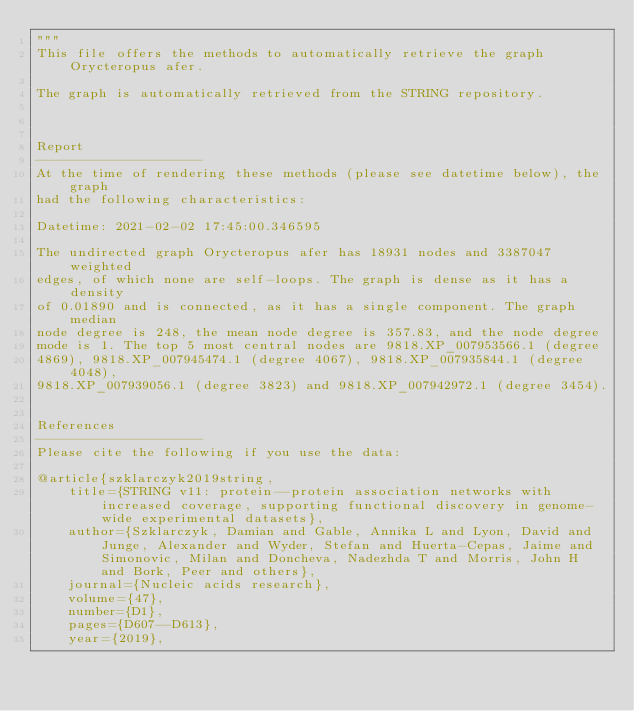Convert code to text. <code><loc_0><loc_0><loc_500><loc_500><_Python_>"""
This file offers the methods to automatically retrieve the graph Orycteropus afer.

The graph is automatically retrieved from the STRING repository. 



Report
---------------------
At the time of rendering these methods (please see datetime below), the graph
had the following characteristics:

Datetime: 2021-02-02 17:45:00.346595

The undirected graph Orycteropus afer has 18931 nodes and 3387047 weighted
edges, of which none are self-loops. The graph is dense as it has a density
of 0.01890 and is connected, as it has a single component. The graph median
node degree is 248, the mean node degree is 357.83, and the node degree
mode is 1. The top 5 most central nodes are 9818.XP_007953566.1 (degree
4869), 9818.XP_007945474.1 (degree 4067), 9818.XP_007935844.1 (degree 4048),
9818.XP_007939056.1 (degree 3823) and 9818.XP_007942972.1 (degree 3454).


References
---------------------
Please cite the following if you use the data:

@article{szklarczyk2019string,
    title={STRING v11: protein--protein association networks with increased coverage, supporting functional discovery in genome-wide experimental datasets},
    author={Szklarczyk, Damian and Gable, Annika L and Lyon, David and Junge, Alexander and Wyder, Stefan and Huerta-Cepas, Jaime and Simonovic, Milan and Doncheva, Nadezhda T and Morris, John H and Bork, Peer and others},
    journal={Nucleic acids research},
    volume={47},
    number={D1},
    pages={D607--D613},
    year={2019},</code> 